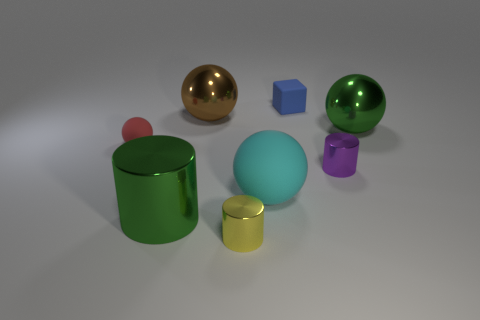Are the yellow object and the green object that is to the left of the cyan matte ball made of the same material?
Make the answer very short. Yes. There is a metallic object on the left side of the large brown metal sphere; what size is it?
Your answer should be very brief. Large. Is the number of small red balls less than the number of tiny metal cubes?
Offer a very short reply. No. Is there a matte object of the same color as the matte cube?
Provide a succinct answer. No. What shape is the big thing that is behind the large rubber thing and right of the yellow object?
Your answer should be compact. Sphere. What is the shape of the metallic object that is behind the large shiny sphere that is on the right side of the yellow metallic cylinder?
Your response must be concise. Sphere. Do the blue thing and the large cyan thing have the same shape?
Offer a very short reply. No. There is a thing that is the same color as the big cylinder; what material is it?
Keep it short and to the point. Metal. Is the big cylinder the same color as the tiny block?
Your answer should be compact. No. How many small yellow cylinders are left of the tiny red rubber object in front of the green metal object behind the tiny purple metal object?
Provide a short and direct response. 0. 